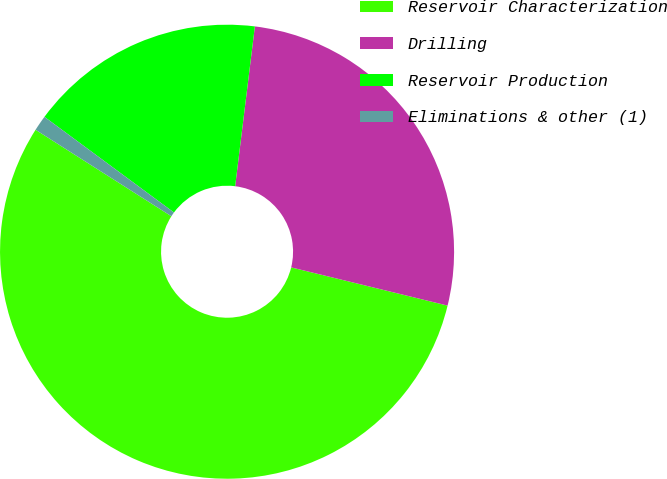<chart> <loc_0><loc_0><loc_500><loc_500><pie_chart><fcel>Reservoir Characterization<fcel>Drilling<fcel>Reservoir Production<fcel>Eliminations & other (1)<nl><fcel>55.21%<fcel>26.86%<fcel>16.83%<fcel>1.1%<nl></chart> 